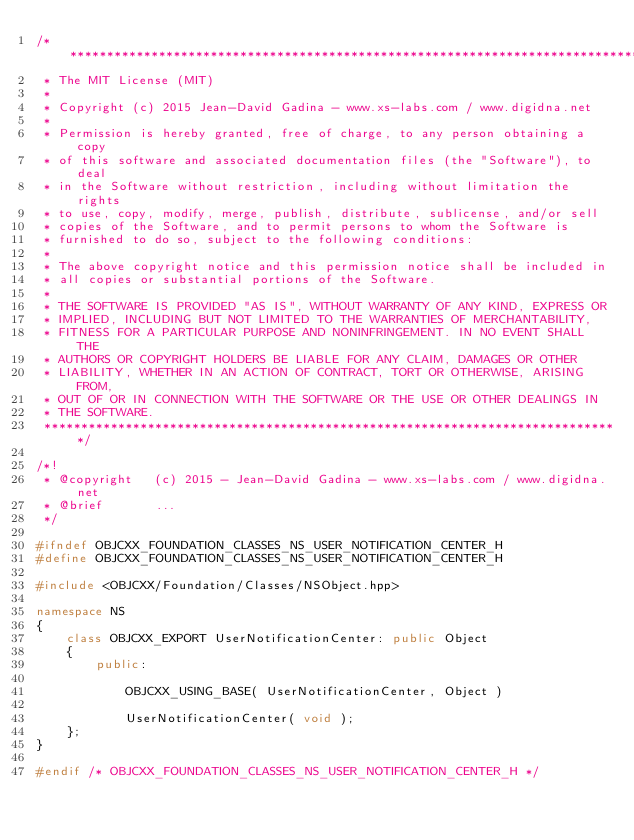<code> <loc_0><loc_0><loc_500><loc_500><_C++_>/*******************************************************************************
 * The MIT License (MIT)
 * 
 * Copyright (c) 2015 Jean-David Gadina - www.xs-labs.com / www.digidna.net
 * 
 * Permission is hereby granted, free of charge, to any person obtaining a copy
 * of this software and associated documentation files (the "Software"), to deal
 * in the Software without restriction, including without limitation the rights
 * to use, copy, modify, merge, publish, distribute, sublicense, and/or sell
 * copies of the Software, and to permit persons to whom the Software is
 * furnished to do so, subject to the following conditions:
 * 
 * The above copyright notice and this permission notice shall be included in
 * all copies or substantial portions of the Software.
 * 
 * THE SOFTWARE IS PROVIDED "AS IS", WITHOUT WARRANTY OF ANY KIND, EXPRESS OR
 * IMPLIED, INCLUDING BUT NOT LIMITED TO THE WARRANTIES OF MERCHANTABILITY,
 * FITNESS FOR A PARTICULAR PURPOSE AND NONINFRINGEMENT. IN NO EVENT SHALL THE
 * AUTHORS OR COPYRIGHT HOLDERS BE LIABLE FOR ANY CLAIM, DAMAGES OR OTHER
 * LIABILITY, WHETHER IN AN ACTION OF CONTRACT, TORT OR OTHERWISE, ARISING FROM,
 * OUT OF OR IN CONNECTION WITH THE SOFTWARE OR THE USE OR OTHER DEALINGS IN
 * THE SOFTWARE.
 ******************************************************************************/

/*!
 * @copyright   (c) 2015 - Jean-David Gadina - www.xs-labs.com / www.digidna.net
 * @brief       ...
 */

#ifndef OBJCXX_FOUNDATION_CLASSES_NS_USER_NOTIFICATION_CENTER_H
#define OBJCXX_FOUNDATION_CLASSES_NS_USER_NOTIFICATION_CENTER_H

#include <OBJCXX/Foundation/Classes/NSObject.hpp>

namespace NS
{
    class OBJCXX_EXPORT UserNotificationCenter: public Object
    {
        public:
            
            OBJCXX_USING_BASE( UserNotificationCenter, Object )
            
            UserNotificationCenter( void );
    };
}

#endif /* OBJCXX_FOUNDATION_CLASSES_NS_USER_NOTIFICATION_CENTER_H */
</code> 